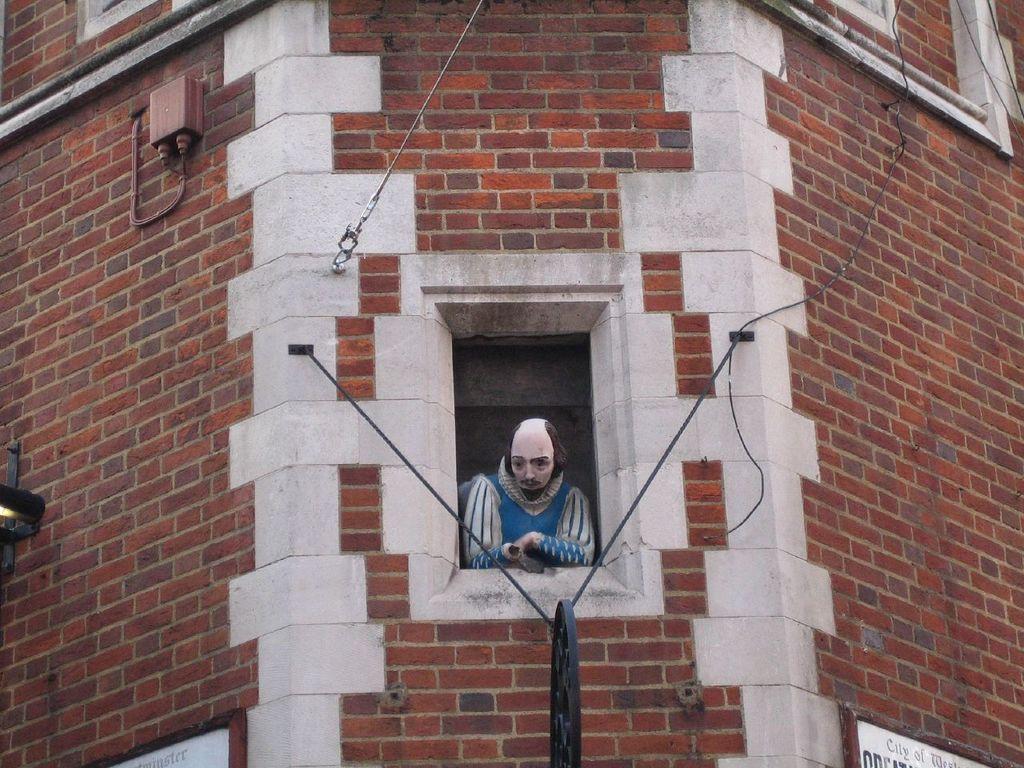Describe this image in one or two sentences. This picture shows a building and we see a human statue from the window and a wheel and we see couple of boards with text to the wall. 